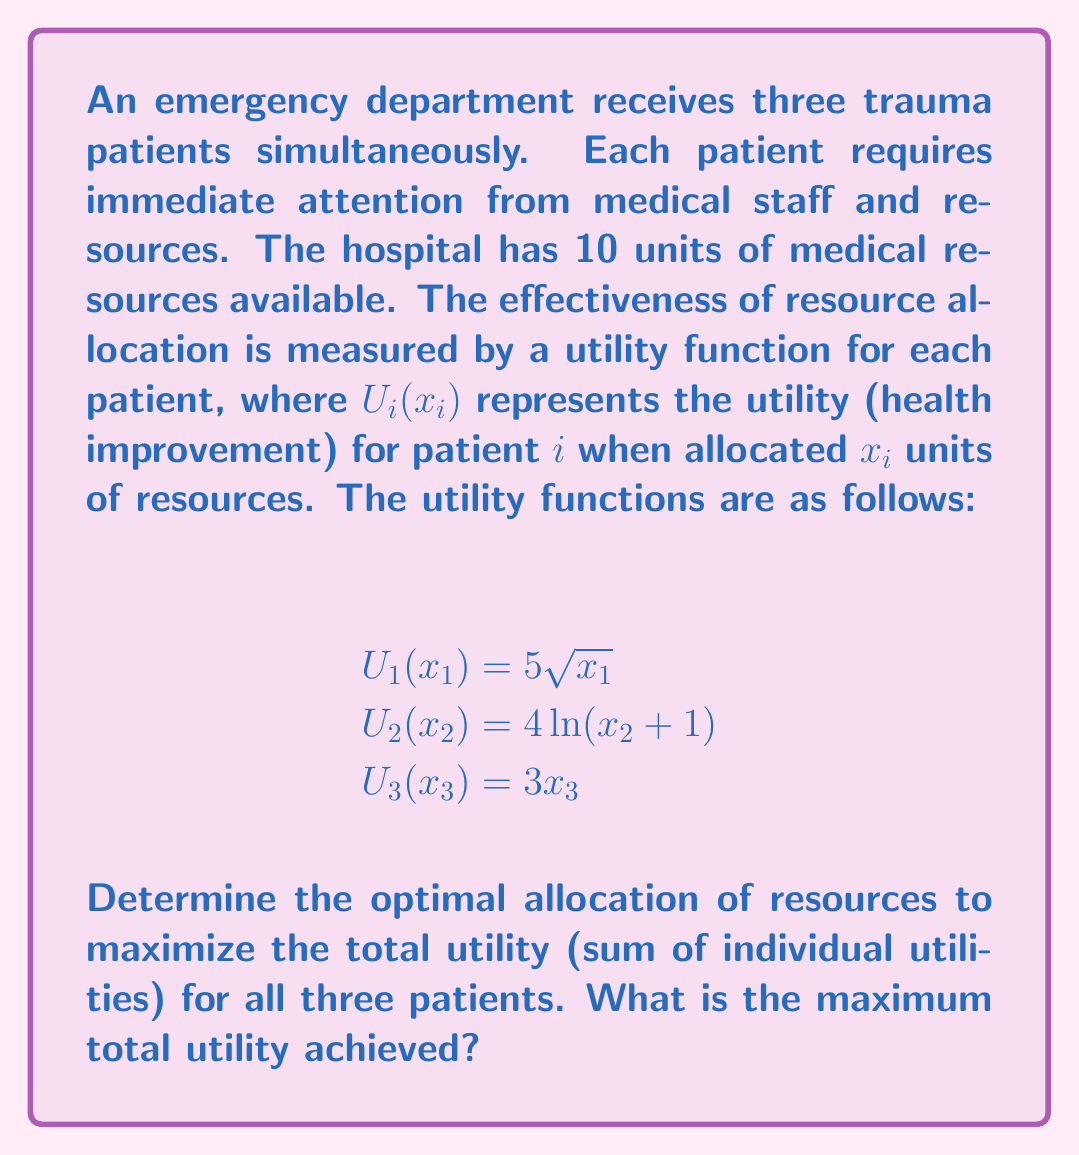Can you answer this question? To solve this optimization problem, we need to maximize the total utility function subject to the resource constraint. Let's approach this step-by-step:

1) The objective function (total utility) to maximize is:
   $$U_{total} = U_1(x_1) + U_2(x_2) + U_3(x_3) = 5\sqrt{x_1} + 4\ln(x_2 + 1) + 3x_3$$

2) The constraint is:
   $$x_1 + x_2 + x_3 = 10$$
   $$x_1, x_2, x_3 \geq 0$$

3) We can use the method of Lagrange multipliers. Let's define the Lagrangian:
   $$L(x_1, x_2, x_3, \lambda) = 5\sqrt{x_1} + 4\ln(x_2 + 1) + 3x_3 - \lambda(x_1 + x_2 + x_3 - 10)$$

4) Now, we take partial derivatives and set them to zero:

   $$\frac{\partial L}{\partial x_1} = \frac{5}{2\sqrt{x_1}} - \lambda = 0$$
   $$\frac{\partial L}{\partial x_2} = \frac{4}{x_2 + 1} - \lambda = 0$$
   $$\frac{\partial L}{\partial x_3} = 3 - \lambda = 0$$
   $$\frac{\partial L}{\partial \lambda} = x_1 + x_2 + x_3 - 10 = 0$$

5) From the third equation, we see that $\lambda = 3$. Substituting this into the first two equations:

   $$\frac{5}{2\sqrt{x_1}} = 3 \implies x_1 = \frac{25}{36} \approx 0.69$$
   $$\frac{4}{x_2 + 1} = 3 \implies x_2 = \frac{1}{3} \approx 0.33$$

6) Using the constraint equation:
   $$x_3 = 10 - x_1 - x_2 = 10 - 0.69 - 0.33 = 8.98$$

7) The optimal allocation is approximately (0.69, 0.33, 8.98).

8) To calculate the maximum total utility:
   $$U_{total} = 5\sqrt{0.69} + 4\ln(0.33 + 1) + 3(8.98) \approx 31.42$$
Answer: The optimal resource allocation is approximately (0.69, 0.33, 8.98) units for patients 1, 2, and 3 respectively. The maximum total utility achieved is approximately 31.42 units. 